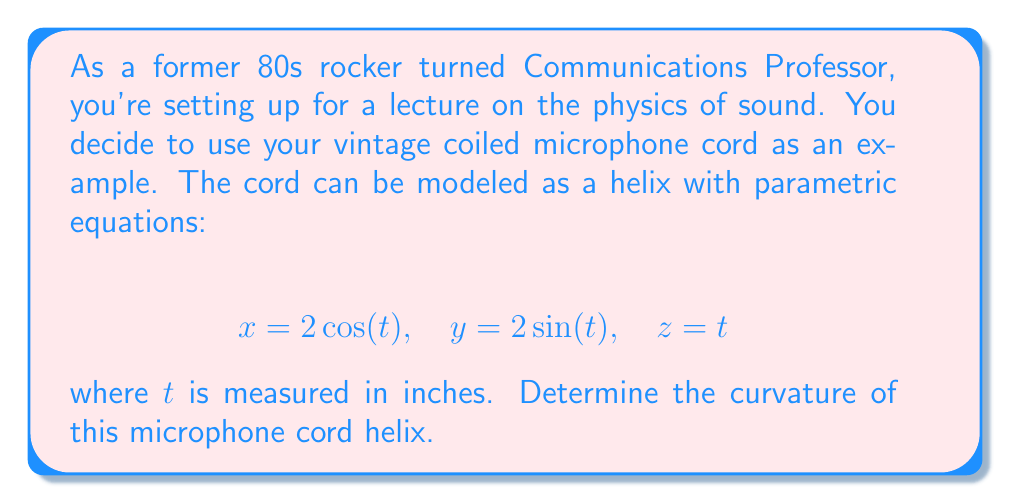Show me your answer to this math problem. To find the curvature of the helix, we'll follow these steps:

1) First, we need to find $\mathbf{r}(t)$, $\mathbf{r}'(t)$, and $\mathbf{r}''(t)$:

   $\mathbf{r}(t) = \langle 2\cos(t), 2\sin(t), t \rangle$

   $\mathbf{r}'(t) = \langle -2\sin(t), 2\cos(t), 1 \rangle$

   $\mathbf{r}''(t) = \langle -2\cos(t), -2\sin(t), 0 \rangle$

2) The curvature formula is:

   $$\kappa = \frac{|\mathbf{r}'(t) \times \mathbf{r}''(t)|}{|\mathbf{r}'(t)|^3}$$

3) Let's calculate $\mathbf{r}'(t) \times \mathbf{r}''(t)$:
   
   $$\begin{vmatrix}
   \mathbf{i} & \mathbf{j} & \mathbf{k} \\
   -2\sin(t) & 2\cos(t) & 1 \\
   -2\cos(t) & -2\sin(t) & 0
   \end{vmatrix}$$

   $= \langle -2\sin(t), -2\cos(t), -4 \rangle$

4) Now, $|\mathbf{r}'(t) \times \mathbf{r}''(t)| = \sqrt{(-2\sin(t))^2 + (-2\cos(t))^2 + (-4)^2} = \sqrt{4\sin^2(t) + 4\cos^2(t) + 16} = \sqrt{20}$

5) Next, calculate $|\mathbf{r}'(t)|$:
   
   $|\mathbf{r}'(t)| = \sqrt{(-2\sin(t))^2 + (2\cos(t))^2 + 1^2} = \sqrt{4\sin^2(t) + 4\cos^2(t) + 1} = \sqrt{5}$

6) Now we can plug these into our curvature formula:

   $$\kappa = \frac{|\mathbf{r}'(t) \times \mathbf{r}''(t)|}{|\mathbf{r}'(t)|^3} = \frac{\sqrt{20}}{(\sqrt{5})^3} = \frac{\sqrt{20}}{5\sqrt{5}}$$

7) Simplify:

   $$\kappa = \frac{2\sqrt{5}}{5\sqrt{5}} = \frac{2}{5}$$
Answer: The curvature of the microphone cord helix is $\frac{2}{5}$ or $0.4$. 